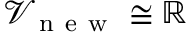<formula> <loc_0><loc_0><loc_500><loc_500>\mathcal { V } _ { n e w } \cong \mathbb { R }</formula> 